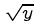<formula> <loc_0><loc_0><loc_500><loc_500>\sqrt { y }</formula> 